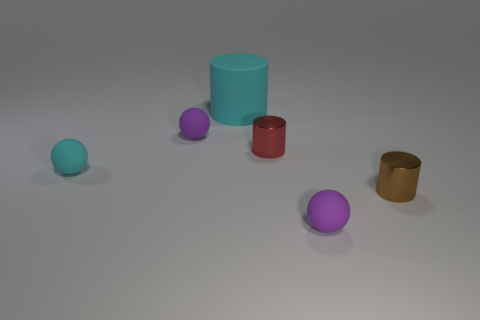Subtract all small cylinders. How many cylinders are left? 1 Subtract all purple blocks. How many purple spheres are left? 2 Add 2 tiny gray matte cylinders. How many objects exist? 8 Subtract all purple rubber objects. Subtract all cyan matte spheres. How many objects are left? 3 Add 2 brown metallic things. How many brown metallic things are left? 3 Add 6 large cyan cylinders. How many large cyan cylinders exist? 7 Subtract 0 gray balls. How many objects are left? 6 Subtract all green cylinders. Subtract all purple cubes. How many cylinders are left? 3 